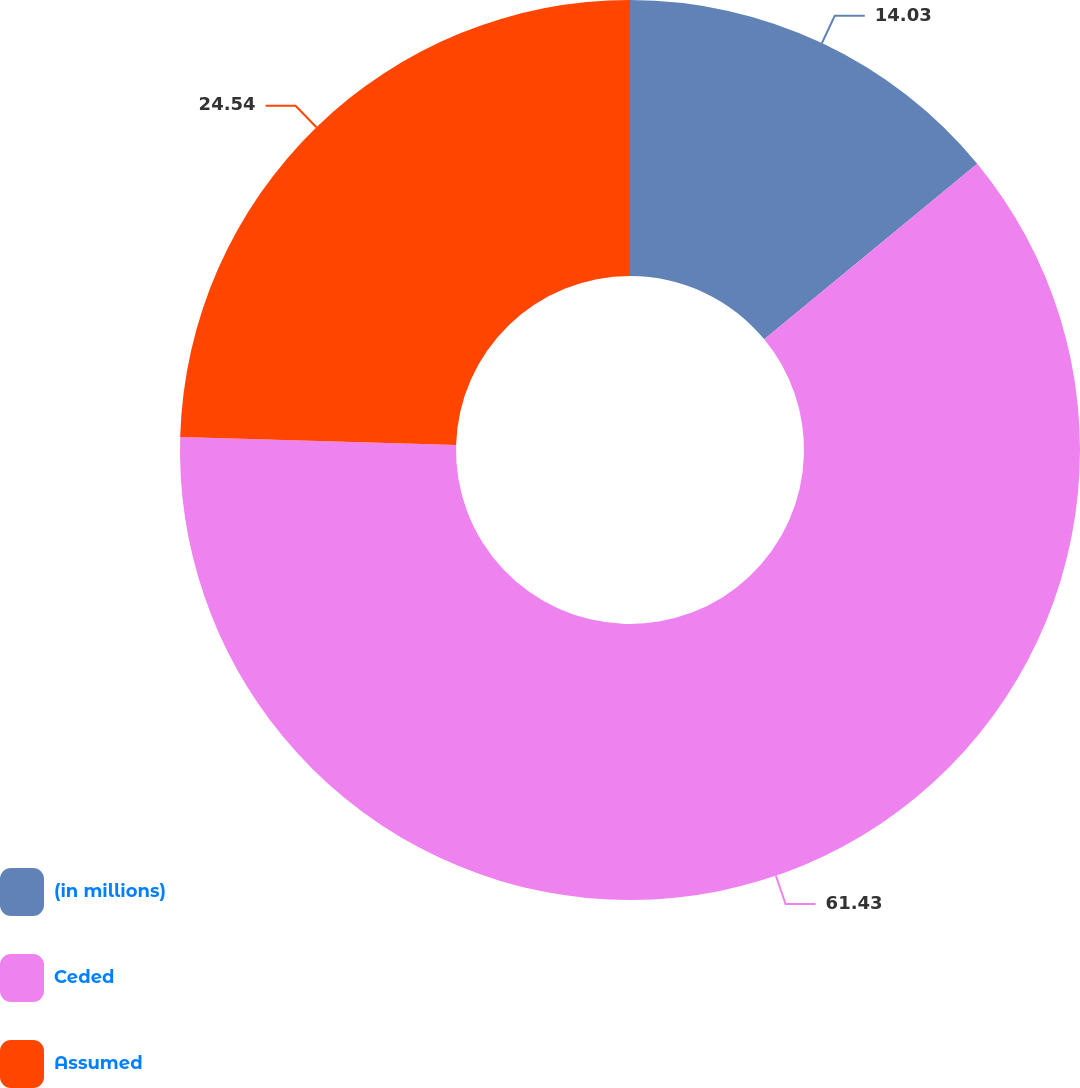Convert chart to OTSL. <chart><loc_0><loc_0><loc_500><loc_500><pie_chart><fcel>(in millions)<fcel>Ceded<fcel>Assumed<nl><fcel>14.03%<fcel>61.44%<fcel>24.54%<nl></chart> 